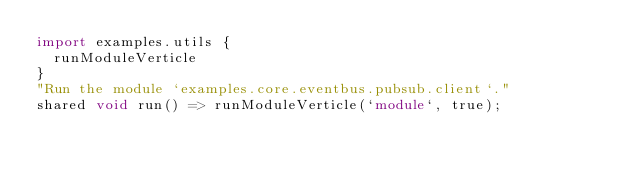<code> <loc_0><loc_0><loc_500><loc_500><_Ceylon_>import examples.utils {
  runModuleVerticle
}
"Run the module `examples.core.eventbus.pubsub.client`."
shared void run() => runModuleVerticle(`module`, true);
</code> 